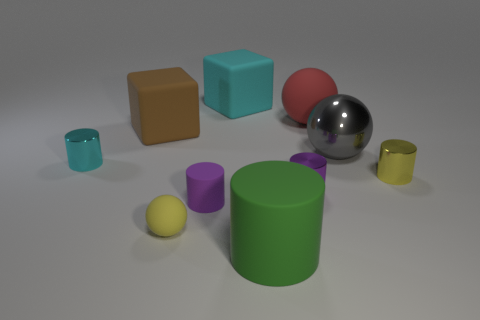Subtract all cyan metallic cylinders. How many cylinders are left? 4 Subtract all cyan cubes. How many cubes are left? 1 Subtract 1 spheres. How many spheres are left? 2 Subtract all cyan balls. Subtract all red cylinders. How many balls are left? 3 Subtract all yellow balls. How many purple cylinders are left? 2 Subtract all large red matte balls. Subtract all tiny yellow rubber balls. How many objects are left? 8 Add 6 tiny purple cylinders. How many tiny purple cylinders are left? 8 Add 6 big cyan objects. How many big cyan objects exist? 7 Subtract 1 brown blocks. How many objects are left? 9 Subtract all blocks. How many objects are left? 8 